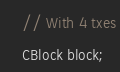<code> <loc_0><loc_0><loc_500><loc_500><_C++_>	// With 4 txes
	CBlock block;</code> 